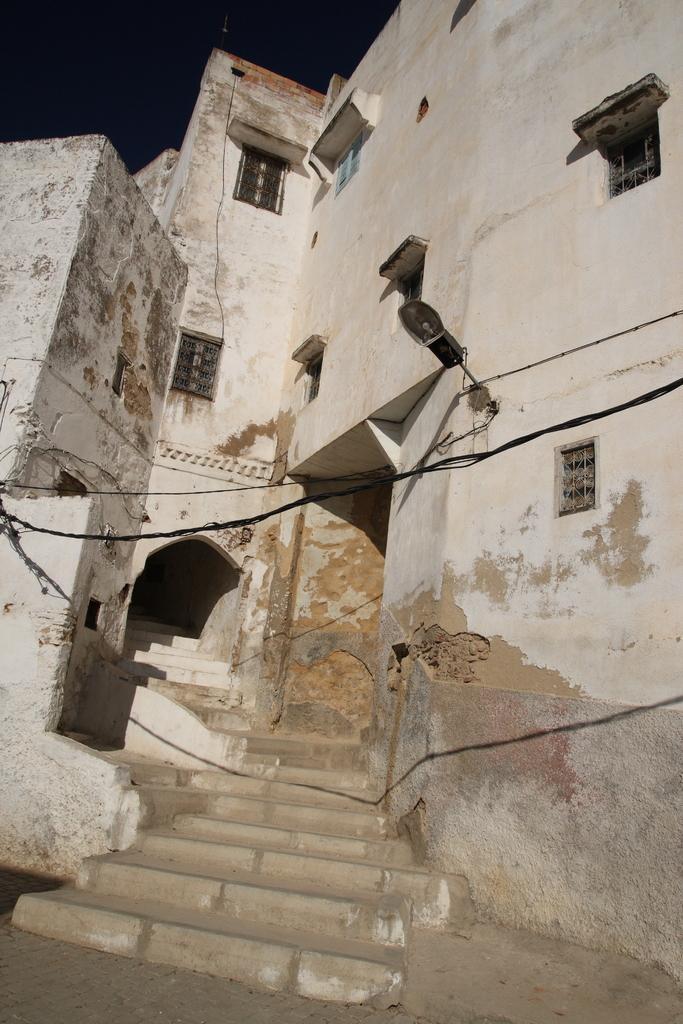Could you give a brief overview of what you see in this image? In this image we can see a building and it has few windows. There is a lamp and few electrical cables in the image. There are staircases in the image. 